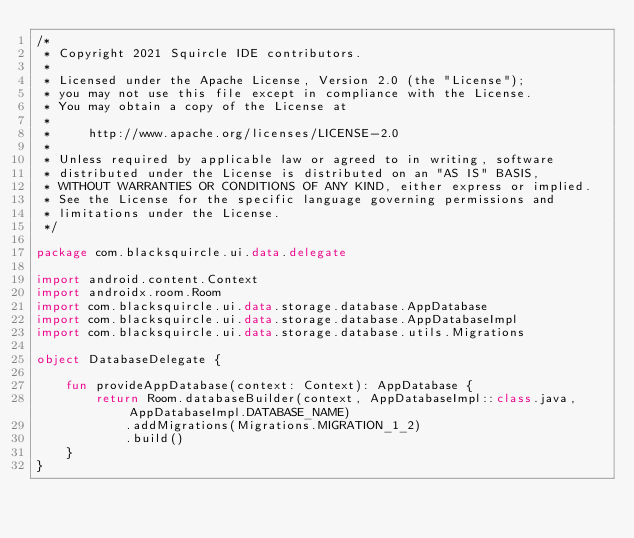<code> <loc_0><loc_0><loc_500><loc_500><_Kotlin_>/*
 * Copyright 2021 Squircle IDE contributors.
 *
 * Licensed under the Apache License, Version 2.0 (the "License");
 * you may not use this file except in compliance with the License.
 * You may obtain a copy of the License at
 *
 *     http://www.apache.org/licenses/LICENSE-2.0
 *
 * Unless required by applicable law or agreed to in writing, software
 * distributed under the License is distributed on an "AS IS" BASIS,
 * WITHOUT WARRANTIES OR CONDITIONS OF ANY KIND, either express or implied.
 * See the License for the specific language governing permissions and
 * limitations under the License.
 */

package com.blacksquircle.ui.data.delegate

import android.content.Context
import androidx.room.Room
import com.blacksquircle.ui.data.storage.database.AppDatabase
import com.blacksquircle.ui.data.storage.database.AppDatabaseImpl
import com.blacksquircle.ui.data.storage.database.utils.Migrations

object DatabaseDelegate {

    fun provideAppDatabase(context: Context): AppDatabase {
        return Room.databaseBuilder(context, AppDatabaseImpl::class.java, AppDatabaseImpl.DATABASE_NAME)
            .addMigrations(Migrations.MIGRATION_1_2)
            .build()
    }
}</code> 